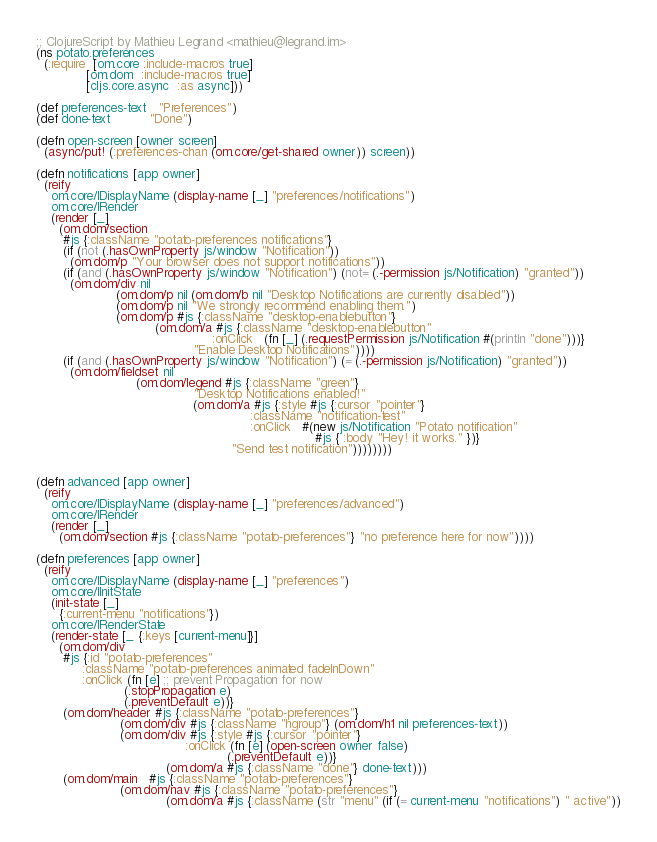Convert code to text. <code><loc_0><loc_0><loc_500><loc_500><_Clojure_>;; ClojureScript by Mathieu Legrand <mathieu@legrand.im>
(ns potato.preferences
  (:require  [om.core :include-macros true]
             [om.dom  :include-macros true]
             [cljs.core.async  :as async]))

(def preferences-text   "Preferences")
(def done-text          "Done")

(defn open-screen [owner screen]
  (async/put! (:preferences-chan (om.core/get-shared owner)) screen))

(defn notifications [app owner]
  (reify
    om.core/IDisplayName (display-name [_] "preferences/notifications")
    om.core/IRender
    (render [_]
      (om.dom/section
       #js {:className "potato-preferences notifications"}
       (if (not (.hasOwnProperty js/window "Notification"))
         (om.dom/p "Your browser does not support notifications"))
       (if (and (.hasOwnProperty js/window "Notification") (not= (.-permission js/Notification) "granted"))
         (om.dom/div nil
                     (om.dom/p nil (om.dom/b nil "Desktop Notifications are currently disabled"))
                     (om.dom/p nil "We strongly recommend enabling them.")
                     (om.dom/p #js {:className "desktop-enablebutton"}
                               (om.dom/a #js {:className "desktop-enablebutton"
                                              :onClick   (fn [_] (.requestPermission js/Notification #(println "done")))}
                                         "Enable Desktop Notifications"))))
       (if (and (.hasOwnProperty js/window "Notification") (= (.-permission js/Notification) "granted"))
         (om.dom/fieldset nil
                          (om.dom/legend #js {:className "green"}
                                         "Desktop Notifications enabled!"
                                         (om.dom/a #js {:style #js {:cursor "pointer"}
                                                        :className "notification-test"
                                                        :onClick   #(new js/Notification "Potato notification"
                                                                         #js { :body "Hey! it works." })}
                                                   "Send test notification"))))))))


(defn advanced [app owner]
  (reify
    om.core/IDisplayName (display-name [_] "preferences/advanced")
    om.core/IRender
    (render [_]
      (om.dom/section #js {:className "potato-preferences"} "no preference here for now"))))

(defn preferences [app owner]
  (reify
    om.core/IDisplayName (display-name [_] "preferences")
    om.core/IInitState
    (init-state [_]
      {:current-menu "notifications"})
    om.core/IRenderState
    (render-state [_ {:keys [current-menu]}]
      (om.dom/div
       #js {:id "potato-preferences"
            :className "potato-preferences animated fadeInDown"
            :onClick (fn [e] ;; prevent Propagation for now
                       (.stopPropagation e)
                       (.preventDefault e))}
       (om.dom/header #js {:className "potato-preferences"}
                      (om.dom/div #js {:className "hgroup"} (om.dom/h1 nil preferences-text))
                      (om.dom/div #js {:style #js {:cursor "pointer"}
                                       :onClick (fn [e] (open-screen owner false)
                                                  (.preventDefault e))}
                                  (om.dom/a #js {:className "done"} done-text)))
       (om.dom/main   #js {:className "potato-preferences"}
                      (om.dom/nav #js {:className "potato-preferences"}
                                  (om.dom/a #js {:className (str "menu" (if (= current-menu "notifications") " active"))</code> 